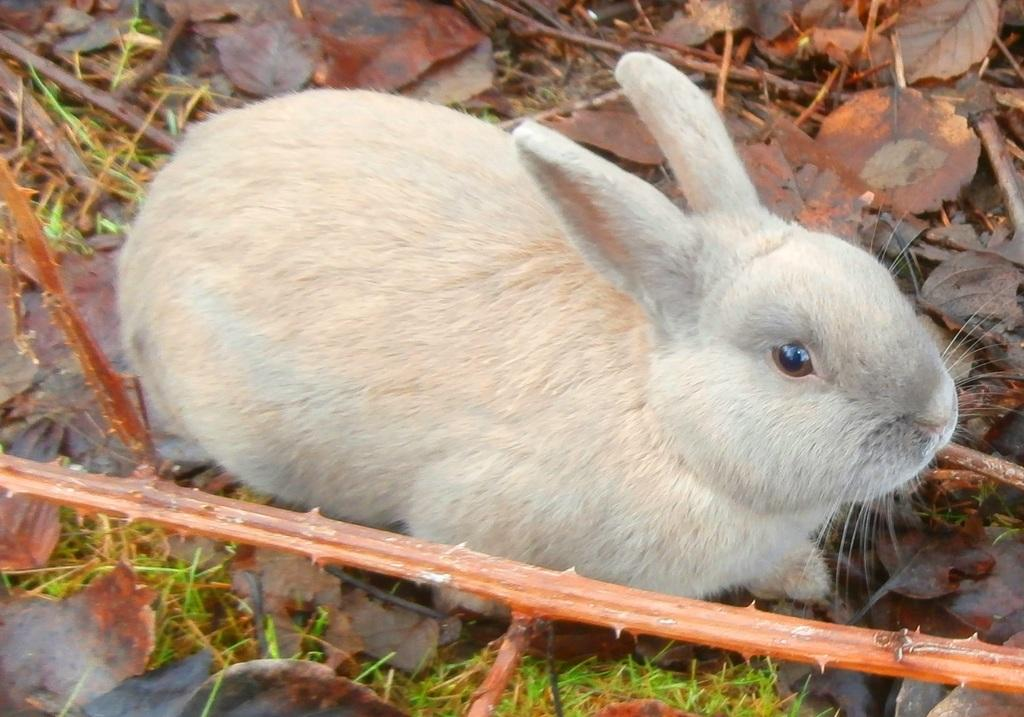What animal is present in the image? There is a rabbit in the image. What color is the rabbit? The rabbit is cream in color. Where is the rabbit sitting? The rabbit is sitting on a surface. What type of vegetation can be seen on the surface? There is grass, dried twigs, and dried leaves on the surface. What type of cable can be seen connecting the rabbit to the town in the image? There is no cable or town present in the image; it features a rabbit sitting on a surface with grass, dried twigs, and dried leaves. 